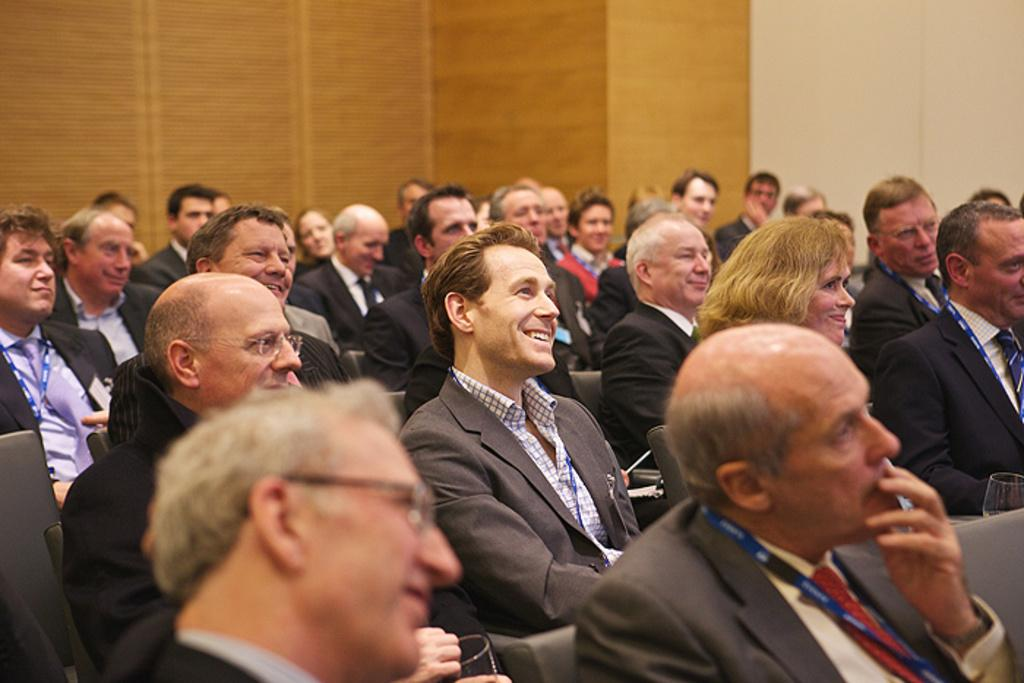What are the people in the image doing? The people in the image are sitting on chairs. What can be seen in the background of the image? There is a wall visible in the background of the image. What type of truck is parked next to the wall in the image? There is no truck present in the image; it only shows people sitting on chairs and a wall in the background. 